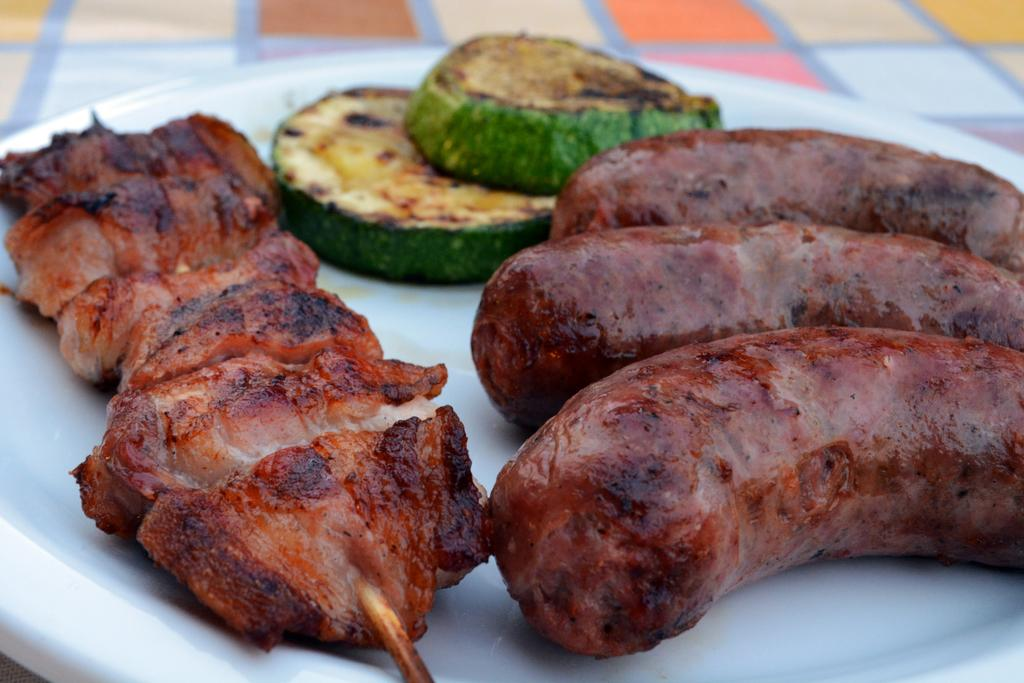What is located in the center of the image? There is a plate in the center of the image. What is on the plate? The plate contains food items. How many bikes are parked next to the plate in the image? There are no bikes present in the image. Is the plate located in a hospital setting in the image? There is no indication of a hospital setting in the image. 